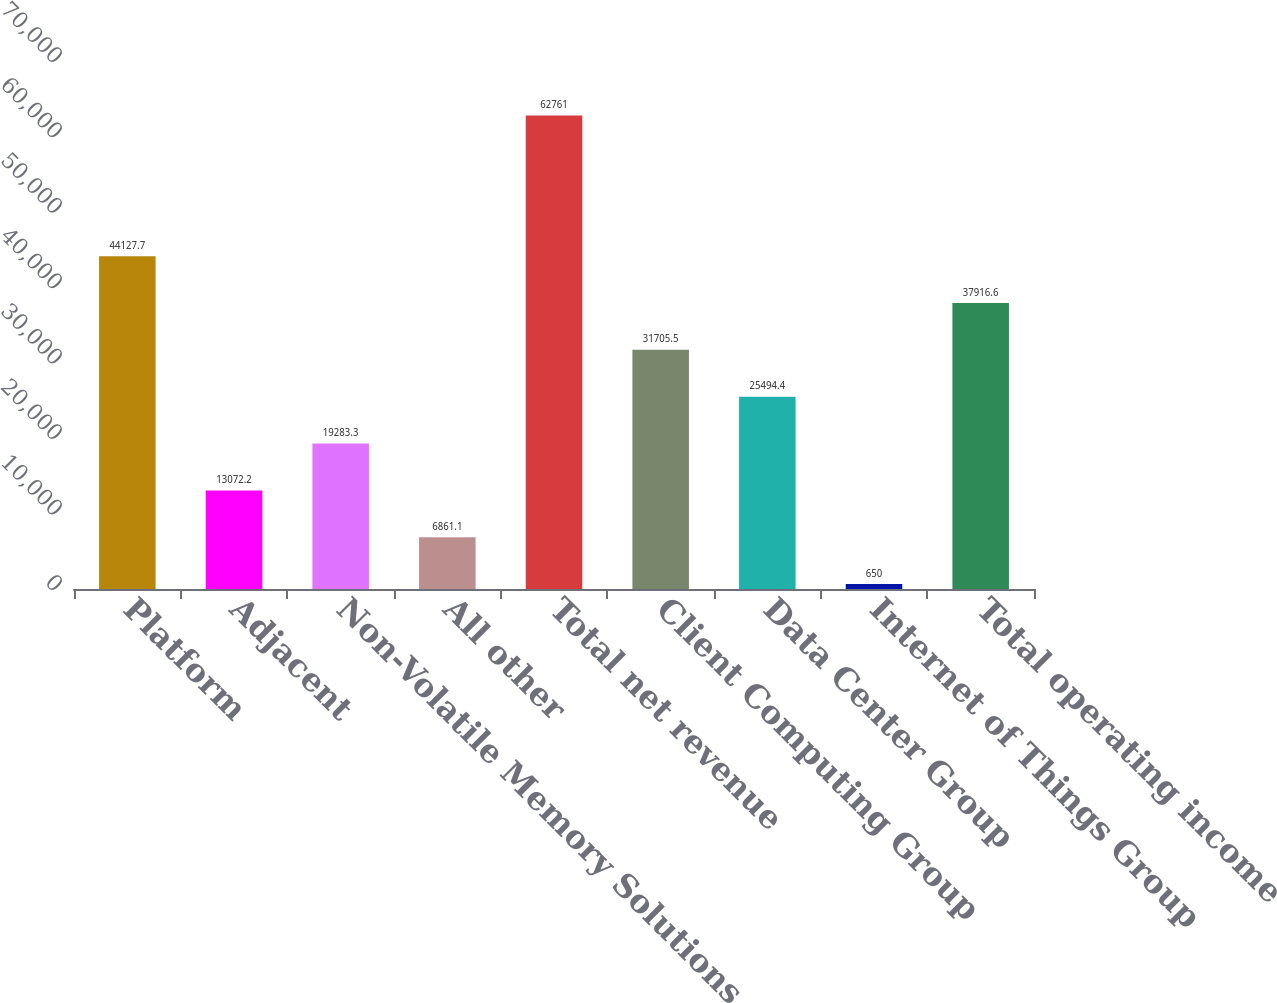<chart> <loc_0><loc_0><loc_500><loc_500><bar_chart><fcel>Platform<fcel>Adjacent<fcel>Non-Volatile Memory Solutions<fcel>All other<fcel>Total net revenue<fcel>Client Computing Group<fcel>Data Center Group<fcel>Internet of Things Group<fcel>Total operating income<nl><fcel>44127.7<fcel>13072.2<fcel>19283.3<fcel>6861.1<fcel>62761<fcel>31705.5<fcel>25494.4<fcel>650<fcel>37916.6<nl></chart> 